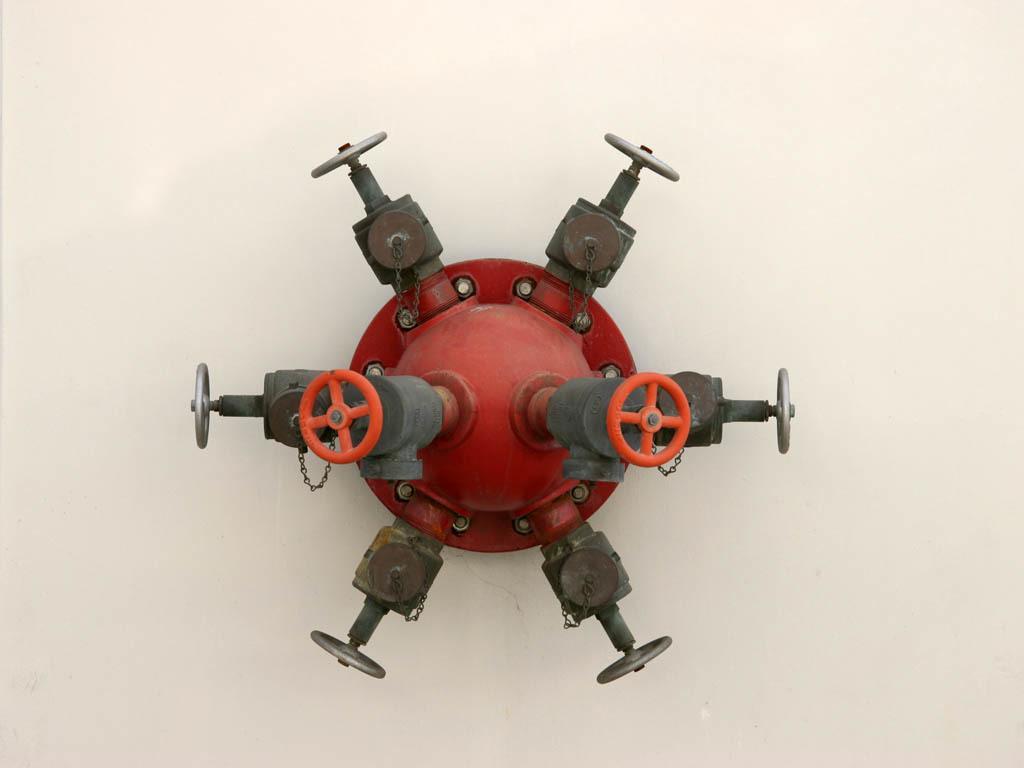Could you give a brief overview of what you see in this image? Here I can see a metal object which is in red color. The background is in white color. 